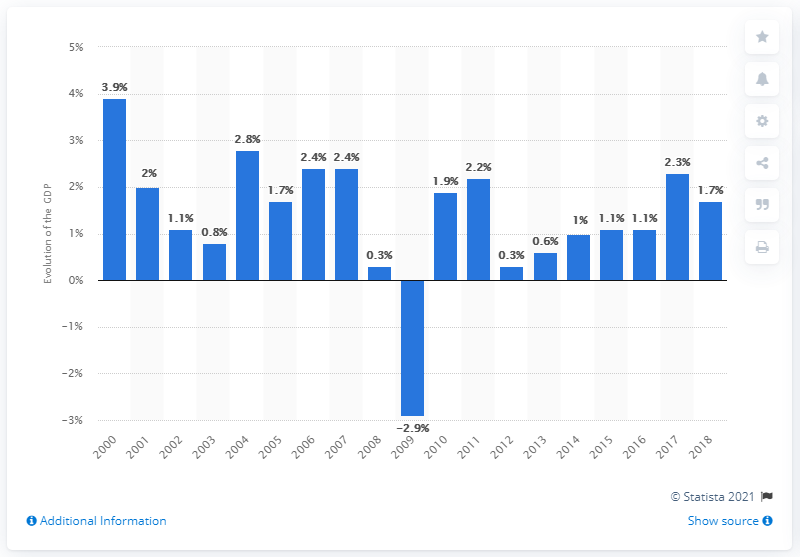Specify some key components in this picture. In 2000, the nominal GDP of France was 3.9 trillion dollars. France's Gross Domestic Product (GDP) increased by 1.7% in 2018. In 2009, France experienced a recession. 